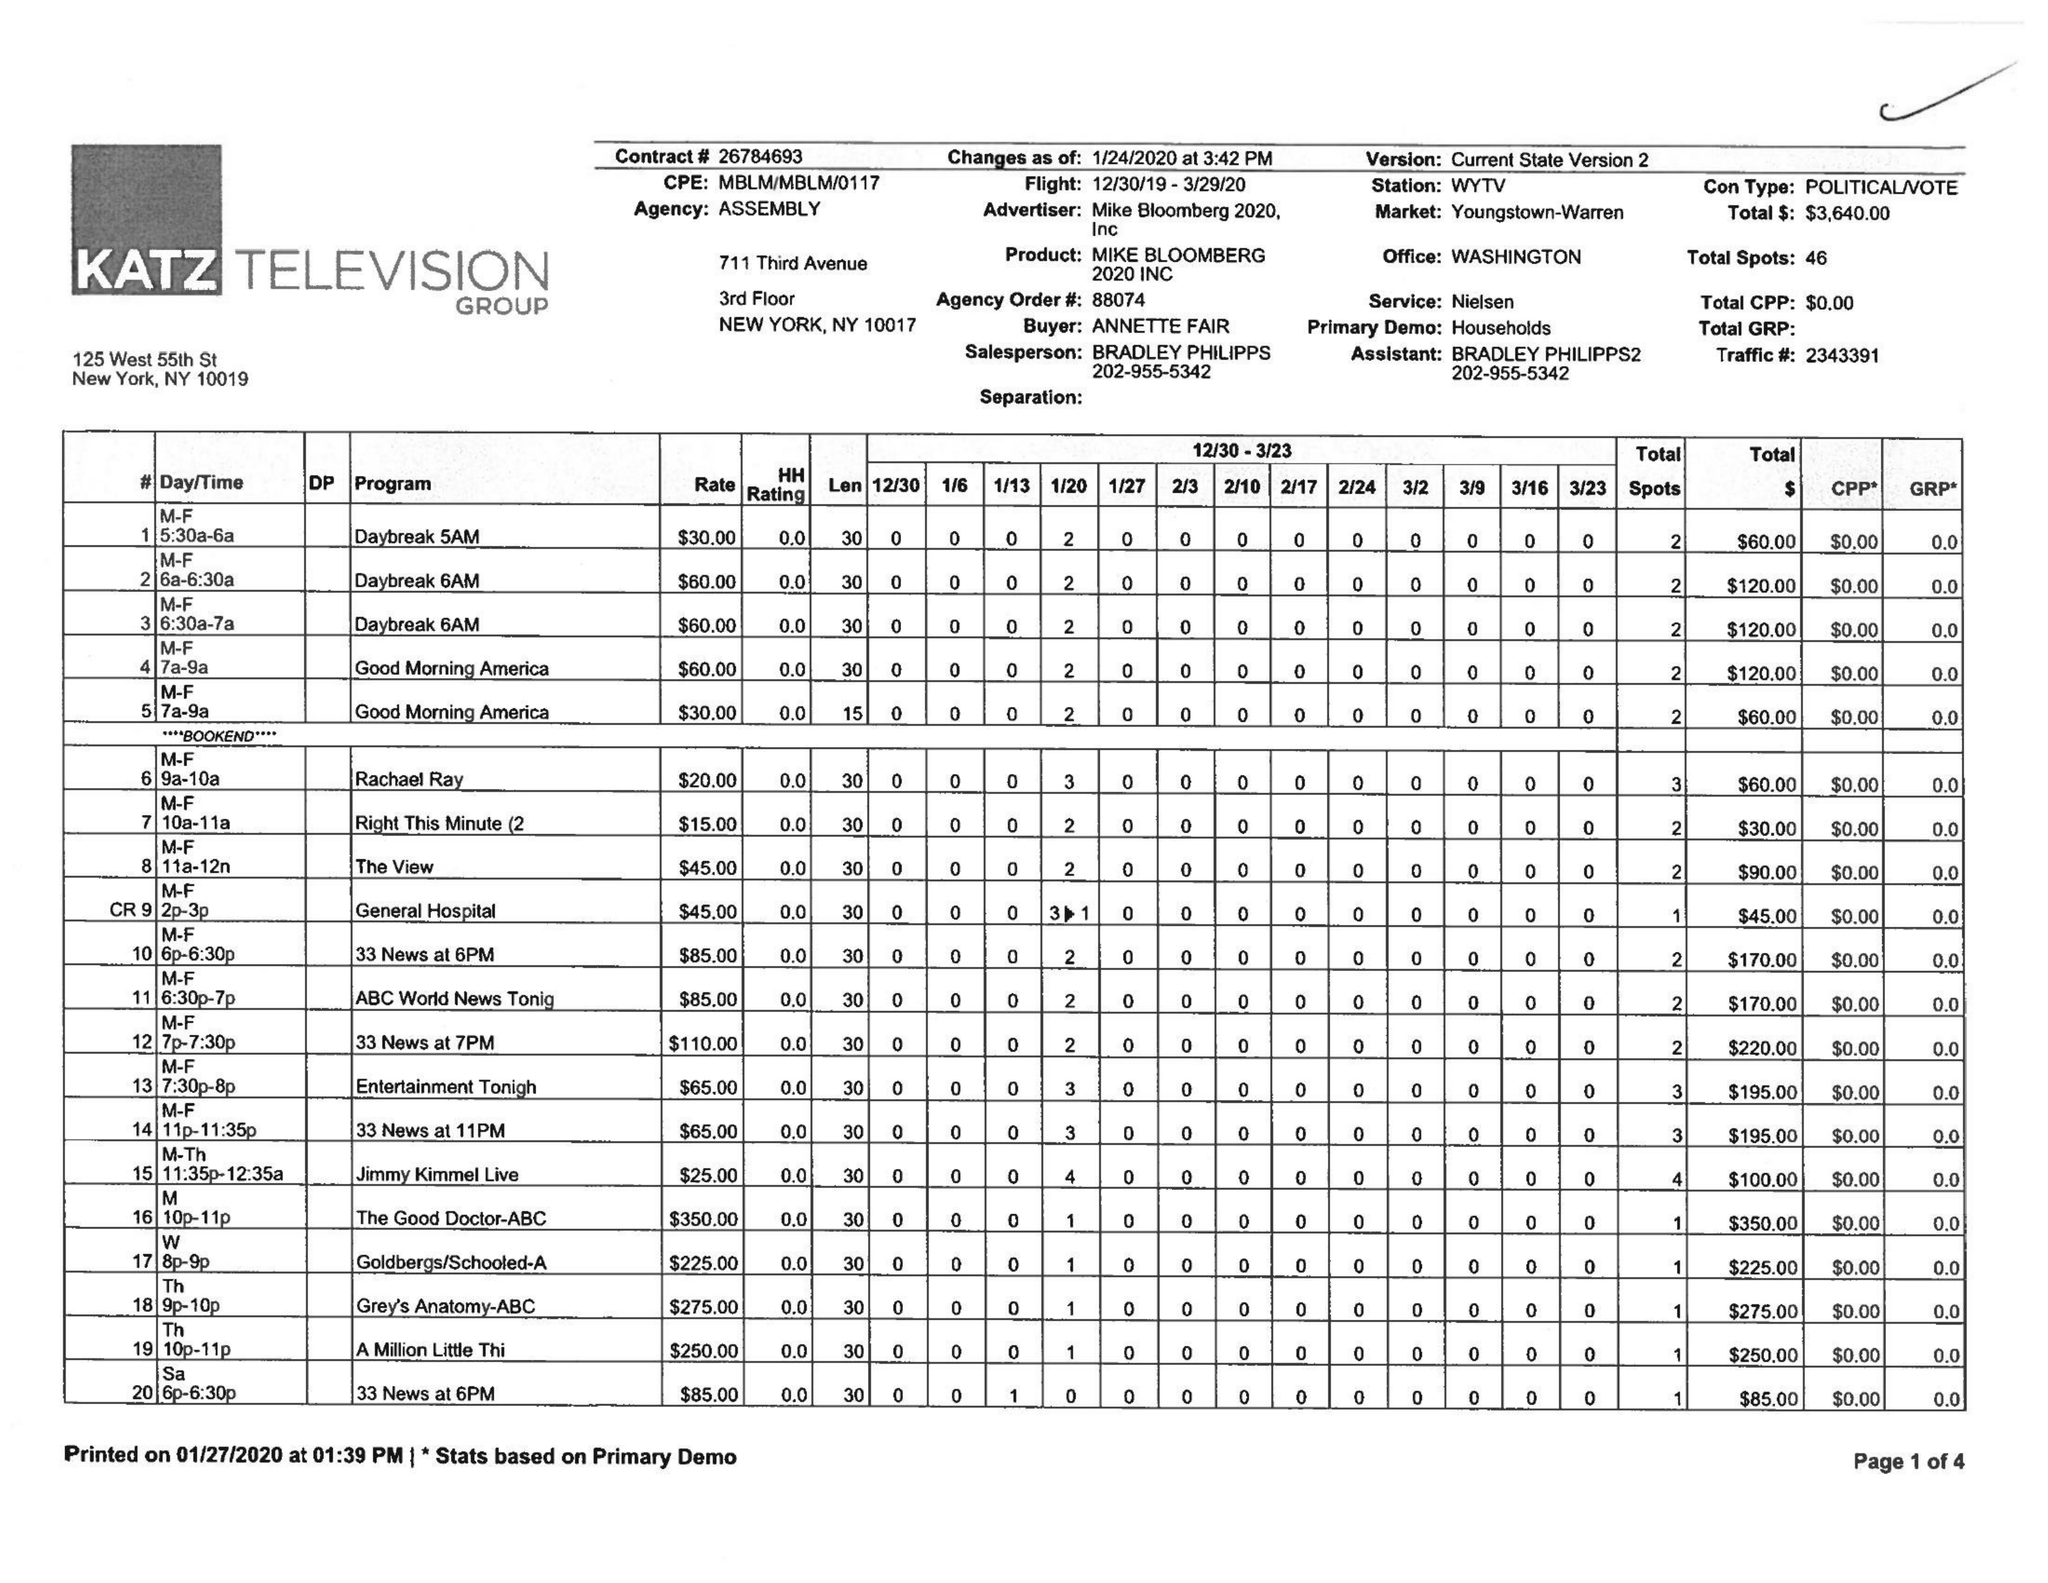What is the value for the flight_from?
Answer the question using a single word or phrase. 12/30/19 